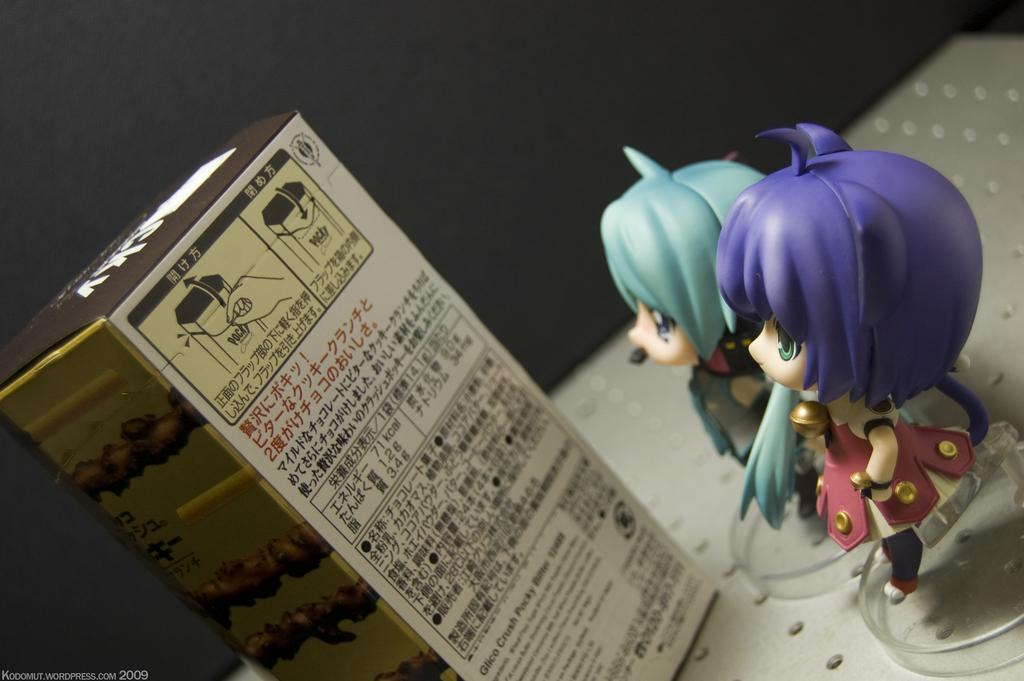What is the main object in the image? There is a box in the image. What else can be seen in the image besides the box? There are two toys in the image. Can you describe the third object in the image? There is an object in the image, but its specific details are not mentioned in the provided facts. Is there any additional feature on the image itself? Yes, there is a watermark on the image. What type of rice is being cooked in the image? There is no rice present in the image. What brand of jeans is the person wearing in the image? There is no person or jeans present in the image. 